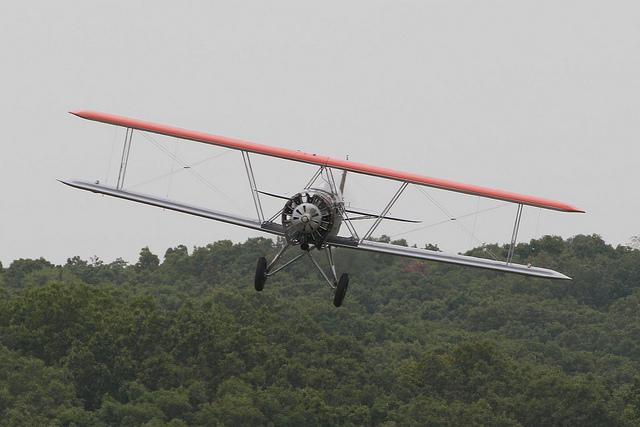Is this a plane built in 2000?
Answer briefly. No. Is this a passenger plane?
Quick response, please. No. What color is the top wing?
Be succinct. Red. 